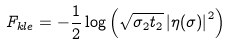Convert formula to latex. <formula><loc_0><loc_0><loc_500><loc_500>\ F _ { k l e } = - \frac { 1 } { 2 } \log \left ( \sqrt { \sigma _ { 2 } t _ { 2 } } \left | \eta ( \sigma ) \right | ^ { 2 } \right )</formula> 